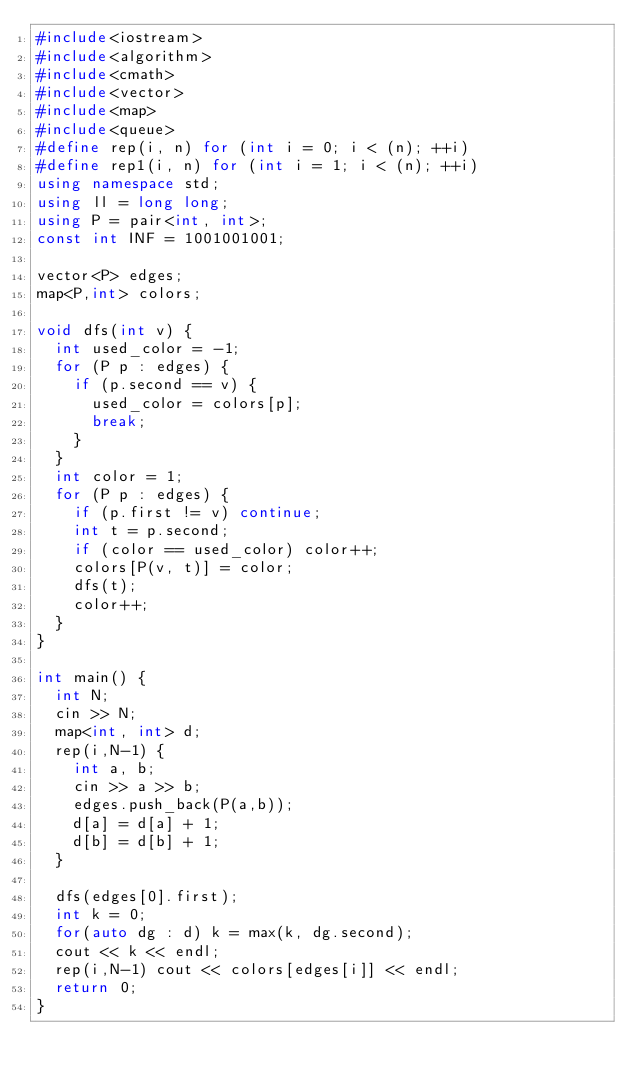Convert code to text. <code><loc_0><loc_0><loc_500><loc_500><_C++_>#include<iostream>
#include<algorithm>
#include<cmath>
#include<vector>
#include<map>
#include<queue>
#define rep(i, n) for (int i = 0; i < (n); ++i)
#define rep1(i, n) for (int i = 1; i < (n); ++i)
using namespace std;
using ll = long long;
using P = pair<int, int>;
const int INF = 1001001001;

vector<P> edges;
map<P,int> colors;

void dfs(int v) {
  int used_color = -1;
  for (P p : edges) {
    if (p.second == v) {
      used_color = colors[p];
      break;
    }
  }
  int color = 1;
  for (P p : edges) {
    if (p.first != v) continue;
    int t = p.second;
    if (color == used_color) color++;
    colors[P(v, t)] = color;
    dfs(t);
    color++;
  }
}

int main() {
  int N;
  cin >> N;
  map<int, int> d;
  rep(i,N-1) {
    int a, b;
    cin >> a >> b;
    edges.push_back(P(a,b));
    d[a] = d[a] + 1;
    d[b] = d[b] + 1;
  }

  dfs(edges[0].first);
  int k = 0;
  for(auto dg : d) k = max(k, dg.second);
  cout << k << endl;
  rep(i,N-1) cout << colors[edges[i]] << endl;
  return 0;
}
</code> 